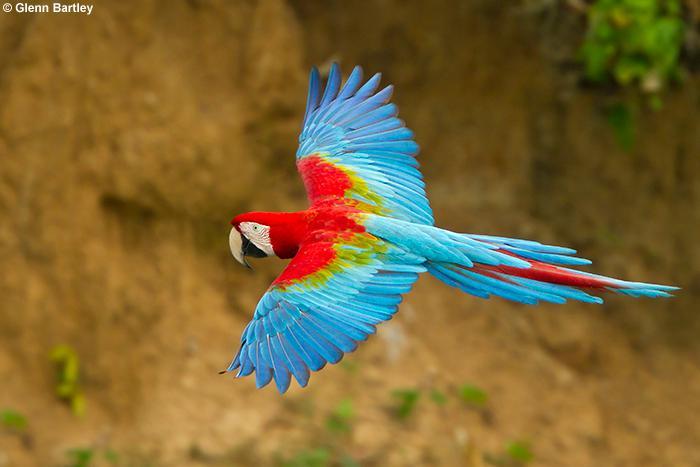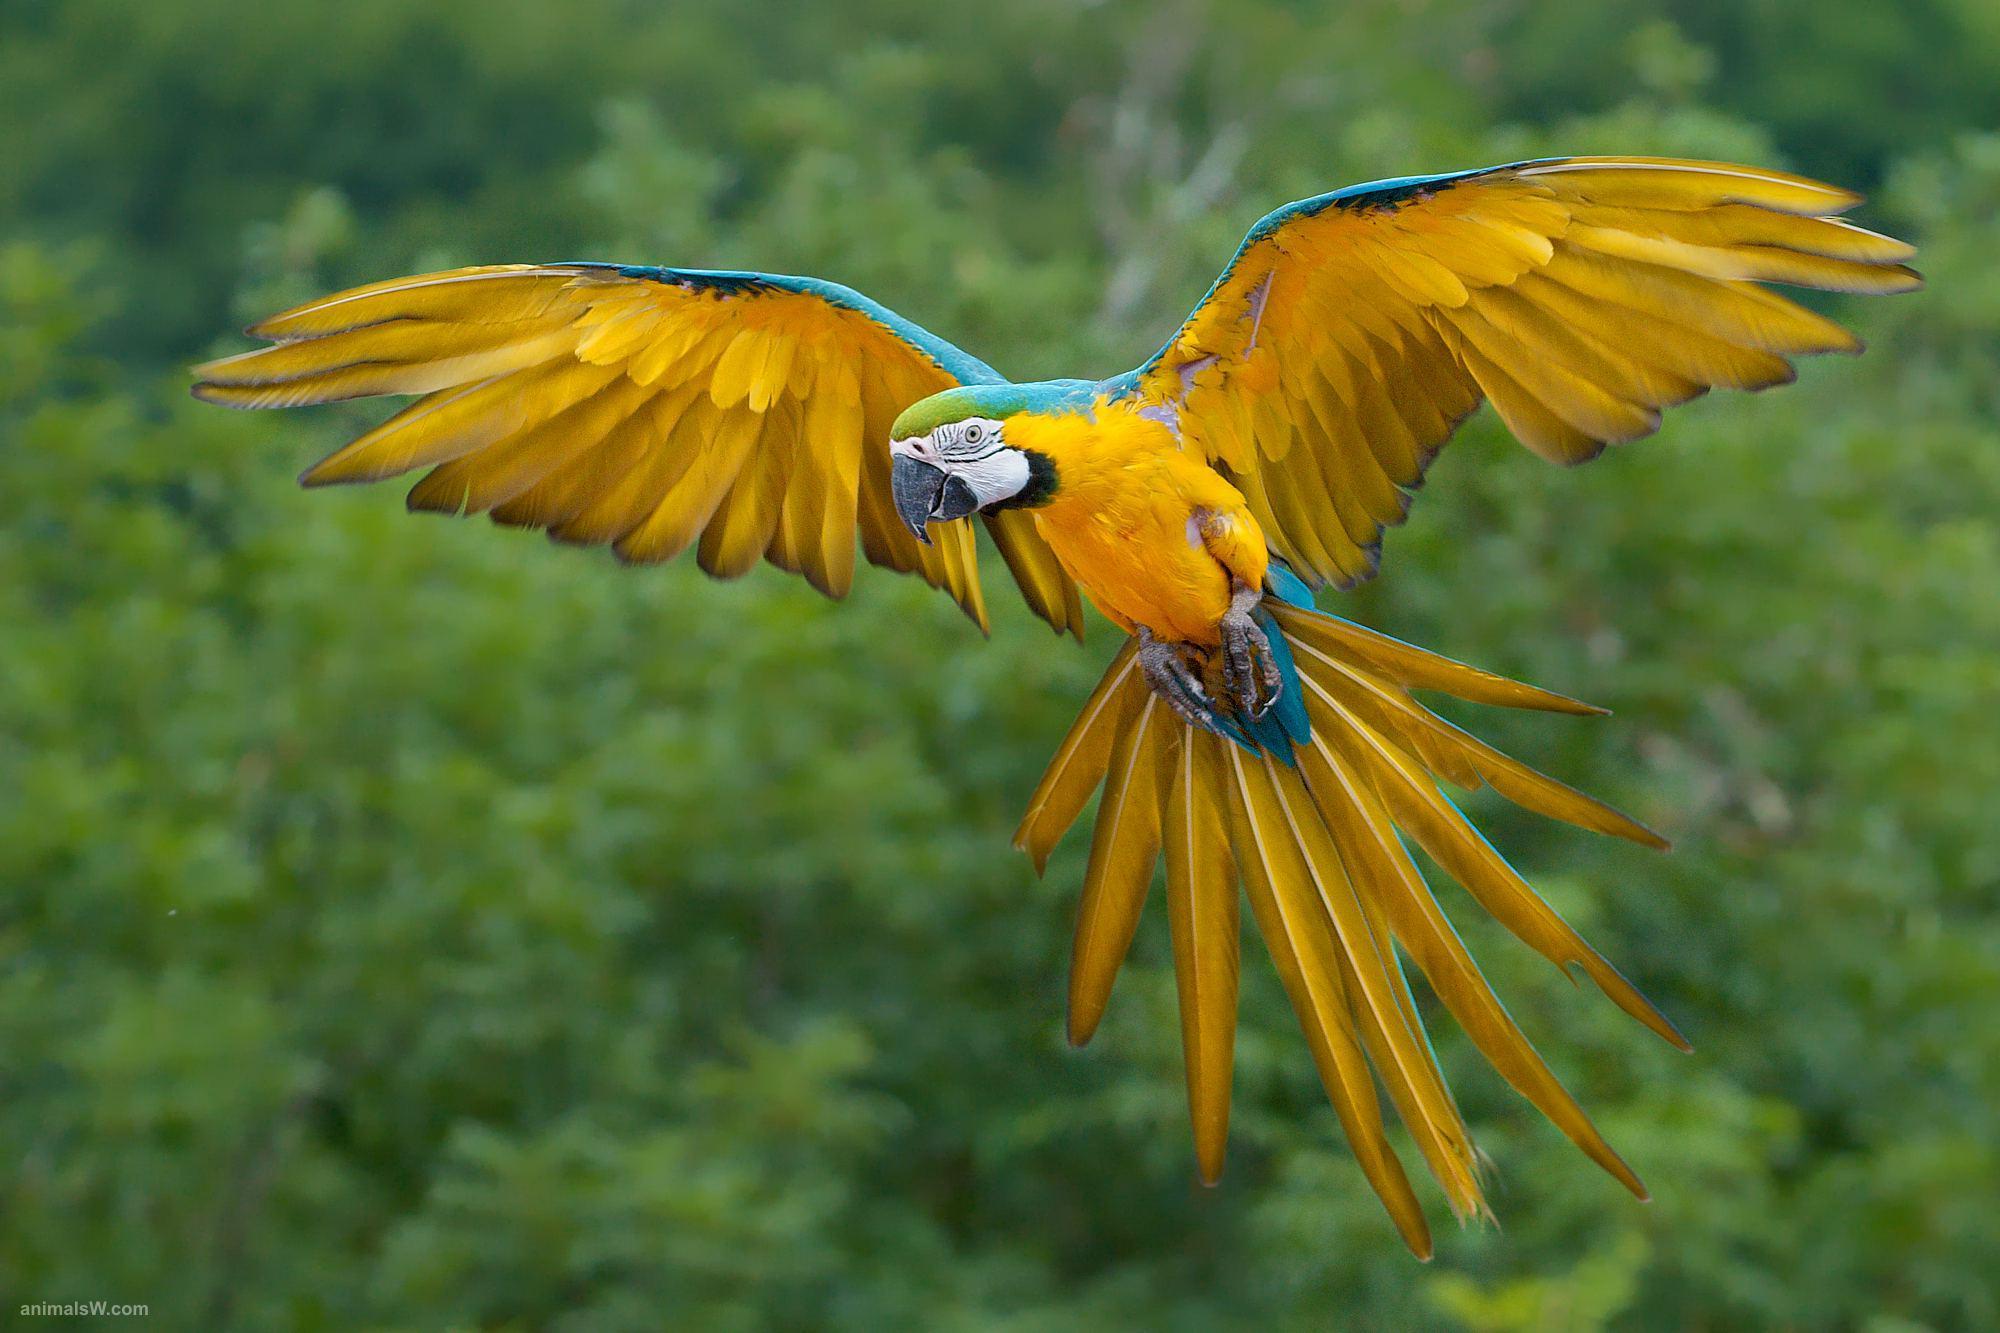The first image is the image on the left, the second image is the image on the right. For the images displayed, is the sentence "The bird in one of the images is flying to the left." factually correct? Answer yes or no. Yes. 